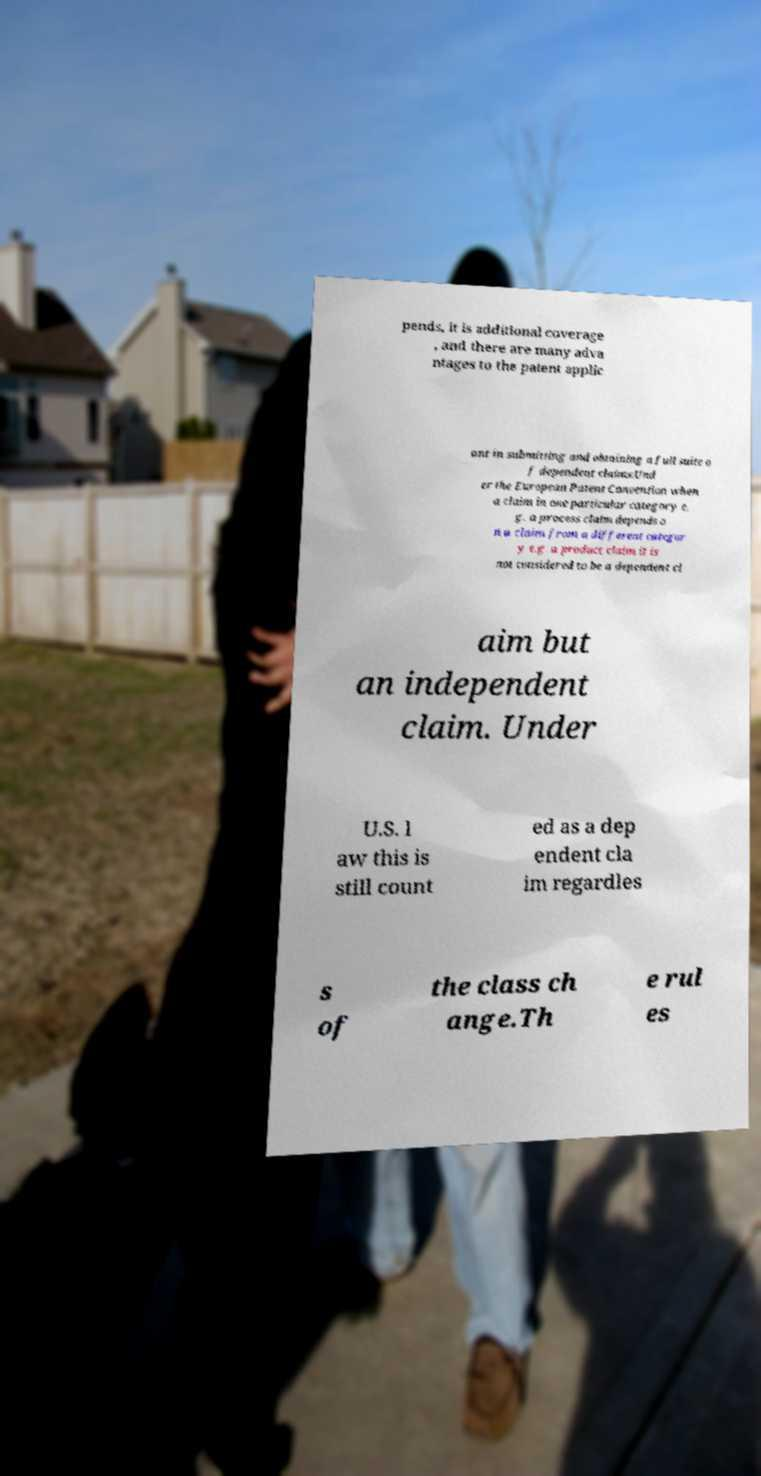What messages or text are displayed in this image? I need them in a readable, typed format. pends, it is additional coverage , and there are many adva ntages to the patent applic ant in submitting and obtaining a full suite o f dependent claims:Und er the European Patent Convention when a claim in one particular category e. g. a process claim depends o n a claim from a different categor y e.g. a product claim it is not considered to be a dependent cl aim but an independent claim. Under U.S. l aw this is still count ed as a dep endent cla im regardles s of the class ch ange.Th e rul es 